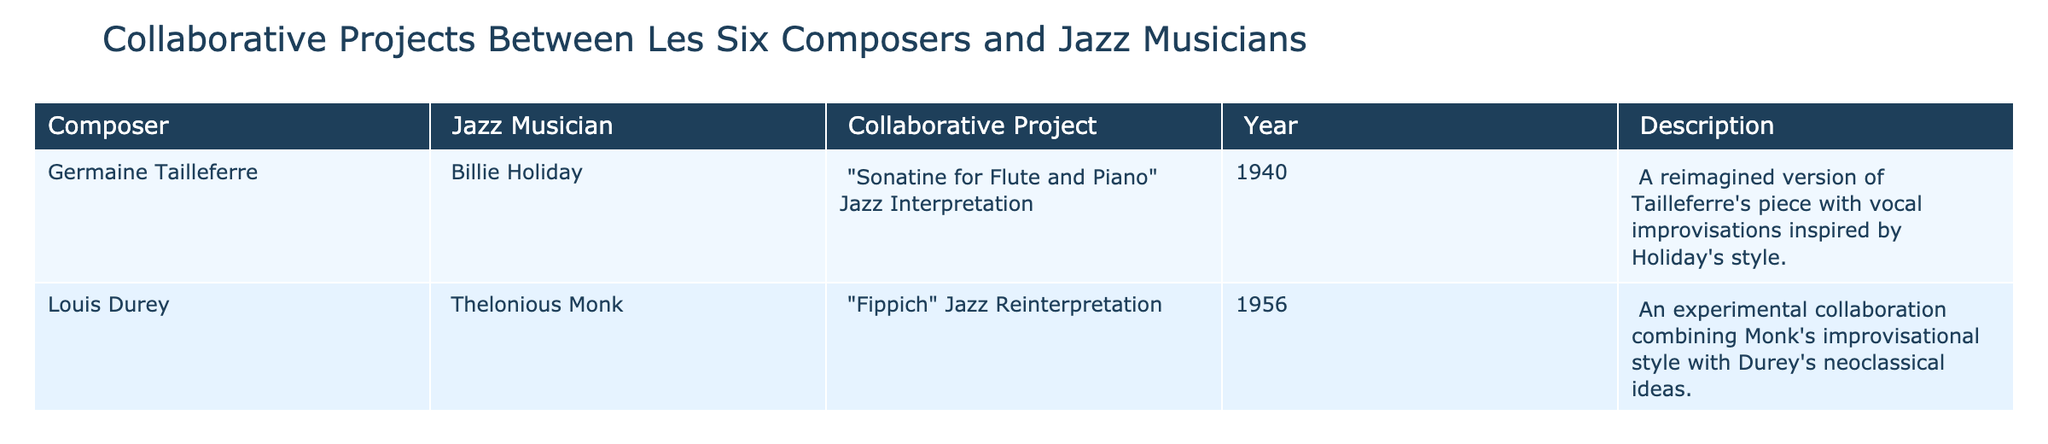What collaborative project involved Germaine Tailleferre and Billie Holiday? The project titled "Sonatine for Flute and Piano" Jazz Interpretation involved Germaine Tailleferre and Billie Holiday. It can be found in the table in the row related to Tailleferre, where it specifies the project and the year 1940.
Answer: Sonatine for Flute and Piano Jazz Interpretation Which jazz musician collaborated with Louis Durey? According to the table, Louis Durey collaborated with Thelonious Monk. This information is available in the corresponding row under the jazz musician column.
Answer: Thelonious Monk What year did the collaboration between Louis Durey and Thelonious Monk occur? The table lists the collaboration between Louis Durey and Thelonious Monk as occurring in 1956, which can be seen in the row associated with that collaboration.
Answer: 1956 Are there any projects that involved both Tailleferre and Durey collaborating with jazz musicians? The table indicates that Tailleferre and Durey each had their own separate collaborations with jazz musicians; thus, there are no joint projects listed. So, the answer is no.
Answer: No What is the common theme in the collaborations listed in the table? The table shows two projects, both of which reinterpret classical compositions with jazz elements. The descriptions highlight vocal improvisations and experimental combinations of styles, illustrating a blending of neoclassicism and jazz.
Answer: The blending of neoclassicism and jazz How many projects involved jazz reinterpretations? The table lists two projects: "Sonatine for Flute and Piano" Jazz Interpretation and "Fippich" Jazz Reinterpretation. Therefore, when these are counted, the total is two projects.
Answer: 2 Which composer had a collaborative project involving vocal improvisations? The project "Sonatine for Flute and Piano" Jazz Interpretation, associated with Germaine Tailleferre, specifically mentions vocal improvisations inspired by Billie Holiday's style. Hence, Tailleferre is the composer in question.
Answer: Germaine Tailleferre Among the collaborative projects, which one was described as experimental? The collaboration titled "Fippich" Jazz Reinterpretation, involving Louis Durey and Thelonious Monk, is noted in the table as an experimental project. The word "experimental" is explicitly used in its description.
Answer: Fippich Jazz Reinterpretation What is the significance of the year 1940 in the table? The year 1940 marks the occurrence of the project "Sonatine for Flute and Piano" Jazz Interpretation, which is associated with Germaine Tailleferre and Billie Holiday, indicating an important moment in the intersecting styles of jazz and classical music.
Answer: 1940 